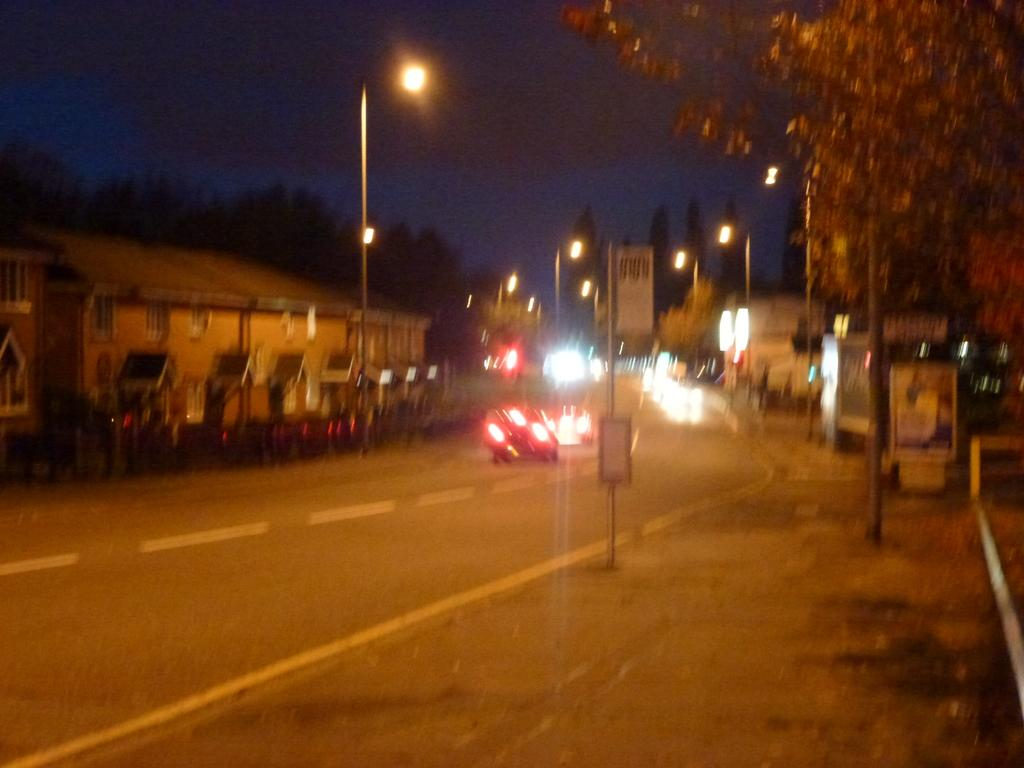What type of structures can be seen in the image? There are buildings in the image. What type of lighting is present in the image? There are pole lights in the image. What is happening on the road in the image? There are vehicles moving on the road in the image. What type of vegetation is present in the image? There are trees in the image. What is attached to the pole in the image? There is a pole with boards in the image. What color is the paint on the clouds in the image? There are no clouds present in the image, so there is no paint on them. How does the person in the image control the vehicles on the road? There is no person in the image controlling the vehicles; they are moving on their own. 